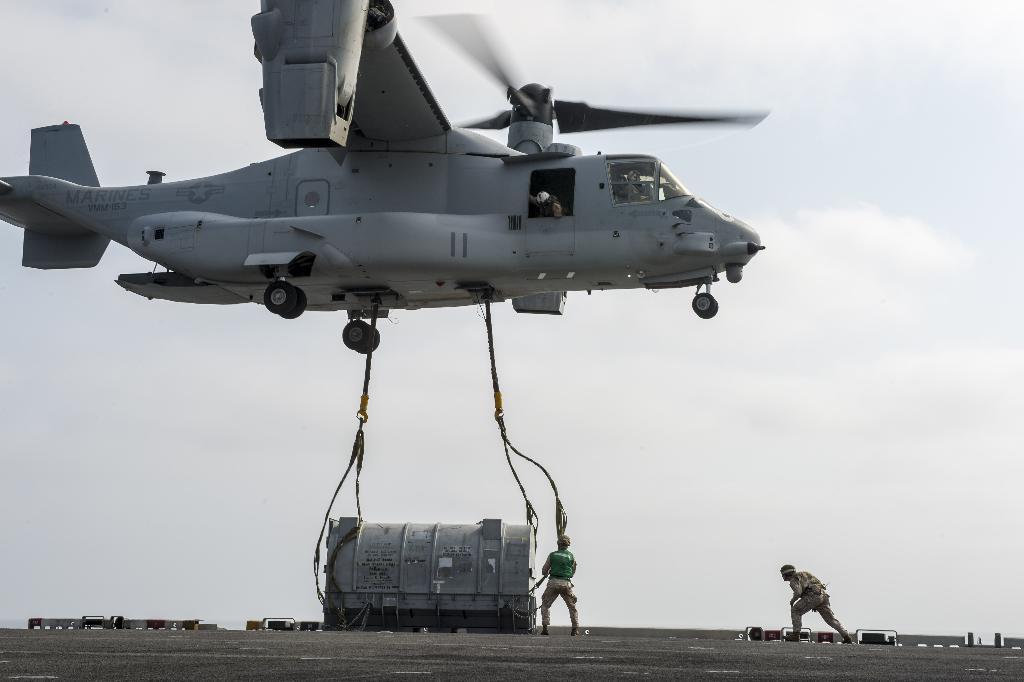Could you give a brief overview of what you see in this image? In this image there are two ropes hanging from the chopper. On the surface there are two workers and there is an object. In the background of the image there are some objects and there is sky. 